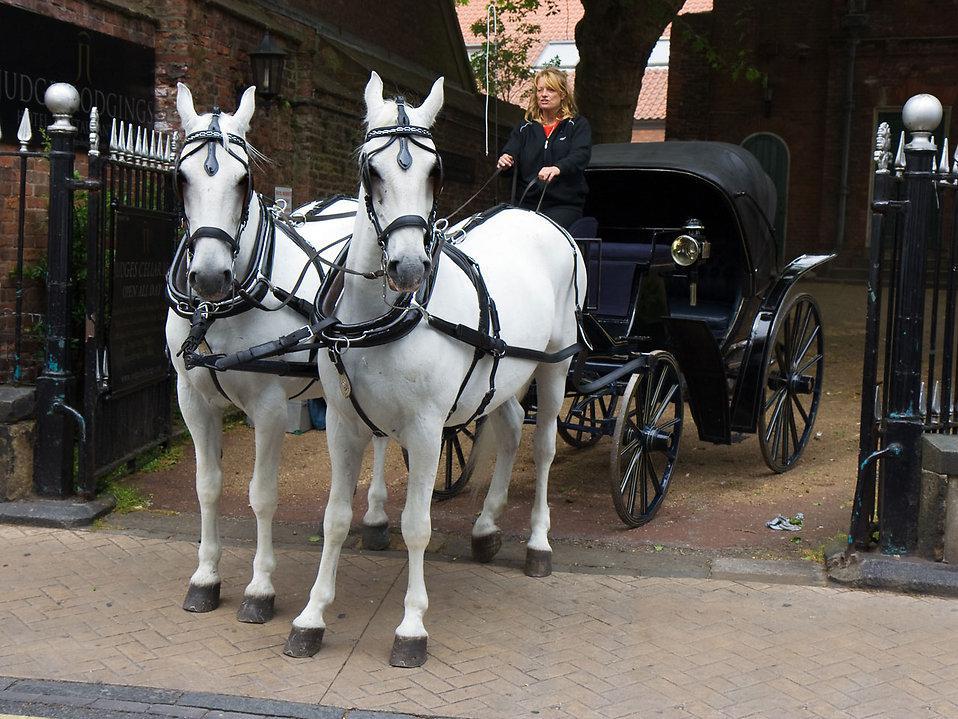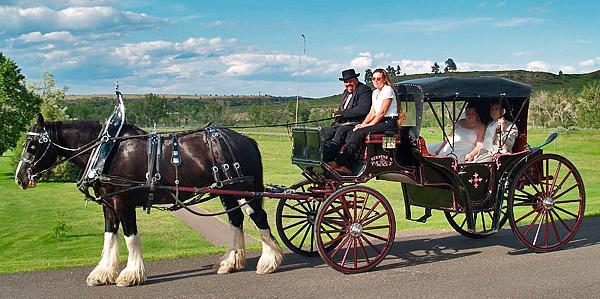The first image is the image on the left, the second image is the image on the right. Considering the images on both sides, is "There is a carriage hitched to a pair of white horses." valid? Answer yes or no. Yes. The first image is the image on the left, the second image is the image on the right. Given the left and right images, does the statement "The horse drawn carriage in the image on the right is against a plain white background." hold true? Answer yes or no. No. 